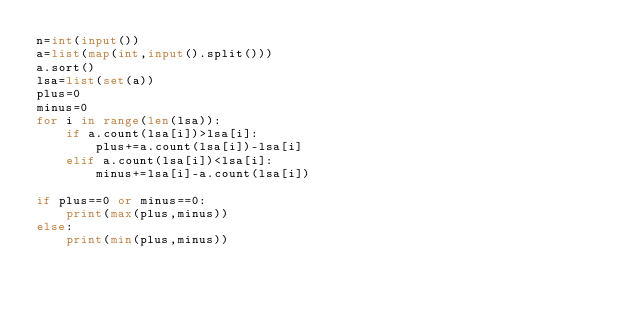<code> <loc_0><loc_0><loc_500><loc_500><_Python_>n=int(input())
a=list(map(int,input().split()))
a.sort()
lsa=list(set(a))
plus=0
minus=0
for i in range(len(lsa)):
    if a.count(lsa[i])>lsa[i]:
        plus+=a.count(lsa[i])-lsa[i]
    elif a.count(lsa[i])<lsa[i]:
        minus+=lsa[i]-a.count(lsa[i])

if plus==0 or minus==0:
    print(max(plus,minus))
else:
    print(min(plus,minus))</code> 